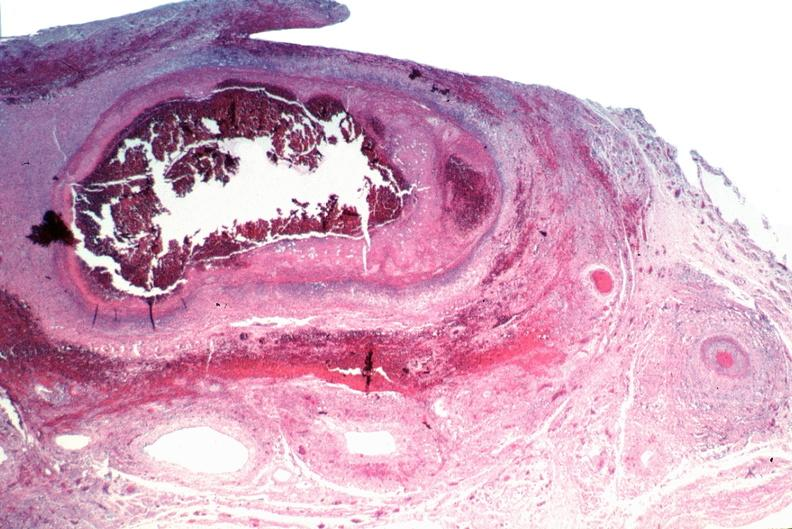does this image show vasculitis, polyarteritis nodosa?
Answer the question using a single word or phrase. Yes 